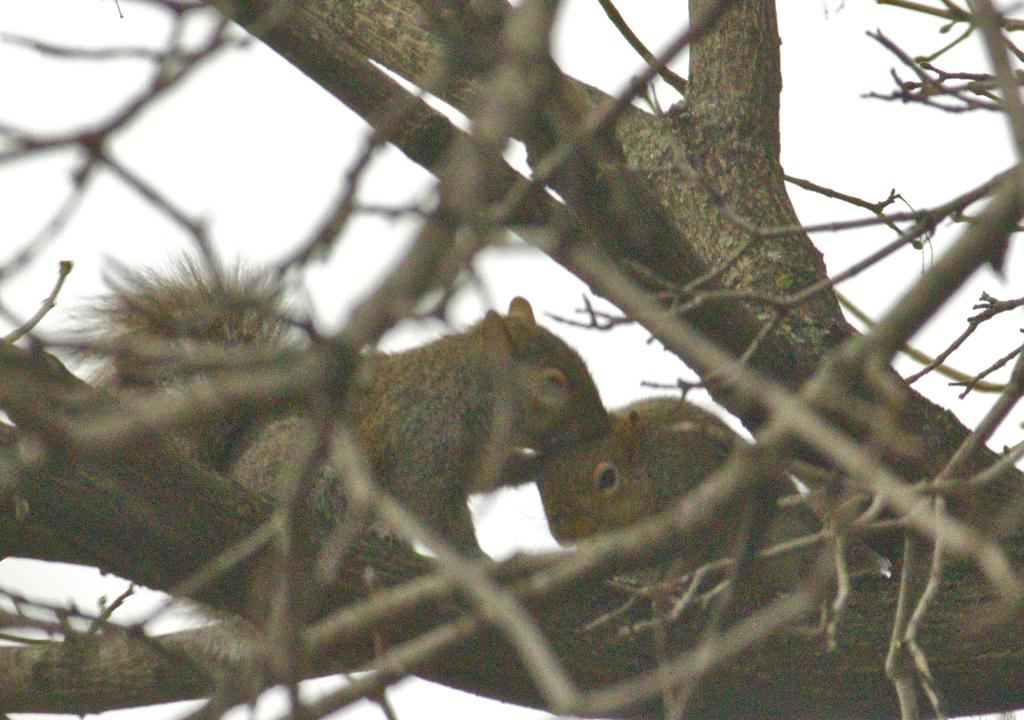How many squirrels are in the image? There are two squirrels in the image. Where are the squirrels located? The squirrels are on a branch of a tree. What can be seen in the background of the image? There are trees and the sky visible in the background of the image. What type of door can be seen in the image? There is no door present in the image; it features two squirrels on a tree branch with trees and the sky in the background. 